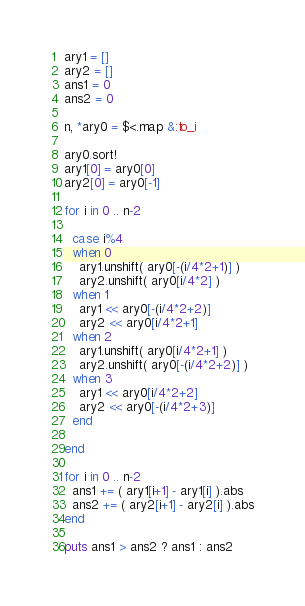Convert code to text. <code><loc_0><loc_0><loc_500><loc_500><_Ruby_>ary1 = []
ary2 = []
ans1 = 0
ans2 = 0

n, *ary0 = $<.map &:to_i

ary0.sort!
ary1[0] = ary0[0]
ary2[0] = ary0[-1]

for i in 0 .. n-2

  case i%4
  when 0
    ary1.unshift( ary0[-(i/4*2+1)] )
    ary2.unshift( ary0[i/4*2] )
  when 1
    ary1 << ary0[-(i/4*2+2)]
    ary2 << ary0[i/4*2+1]
  when 2
    ary1.unshift( ary0[i/4*2+1] )
    ary2.unshift( ary0[-(i/4*2+2)] )
  when 3
    ary1 << ary0[i/4*2+2]
    ary2 << ary0[-(i/4*2+3)]
  end

end

for i in 0 .. n-2
  ans1 += ( ary1[i+1] - ary1[i] ).abs
  ans2 += ( ary2[i+1] - ary2[i] ).abs
end

puts ans1 > ans2 ? ans1 : ans2
</code> 